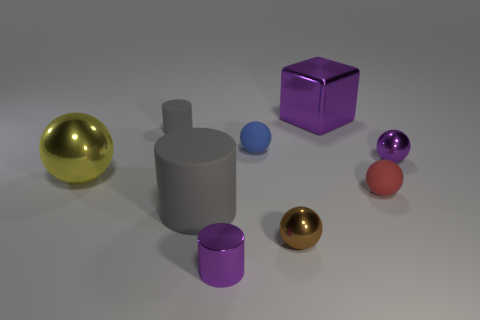There is a object that is both behind the blue object and on the left side of the big metallic block; what is its shape? The object positioned behind the blue sphere and to the left of the large metallic block is a cylinder. It appears to be standing upright with its circular base resting on the surface. 